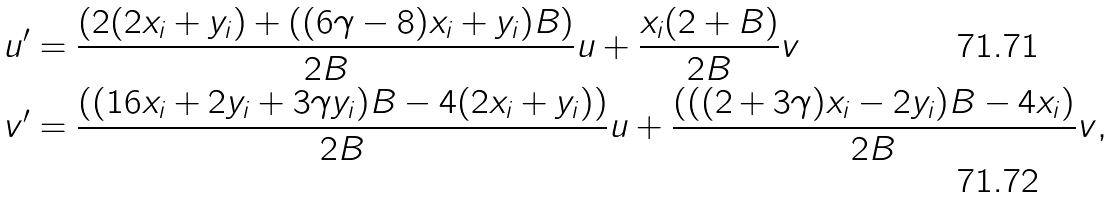Convert formula to latex. <formula><loc_0><loc_0><loc_500><loc_500>u ^ { \prime } & = \frac { ( 2 ( 2 x _ { i } + y _ { i } ) + ( ( 6 \gamma - 8 ) x _ { i } + y _ { i } ) B ) } { 2 B } u + \frac { x _ { i } ( 2 + B ) } { 2 B } v \\ v ^ { \prime } & = \frac { ( ( 1 6 x _ { i } + 2 y _ { i } + 3 \gamma y _ { i } ) B - 4 ( 2 x _ { i } + y _ { i } ) ) } { 2 B } u + \frac { ( ( ( 2 + 3 \gamma ) x _ { i } - 2 y _ { i } ) B - 4 x _ { i } ) } { 2 B } v ,</formula> 